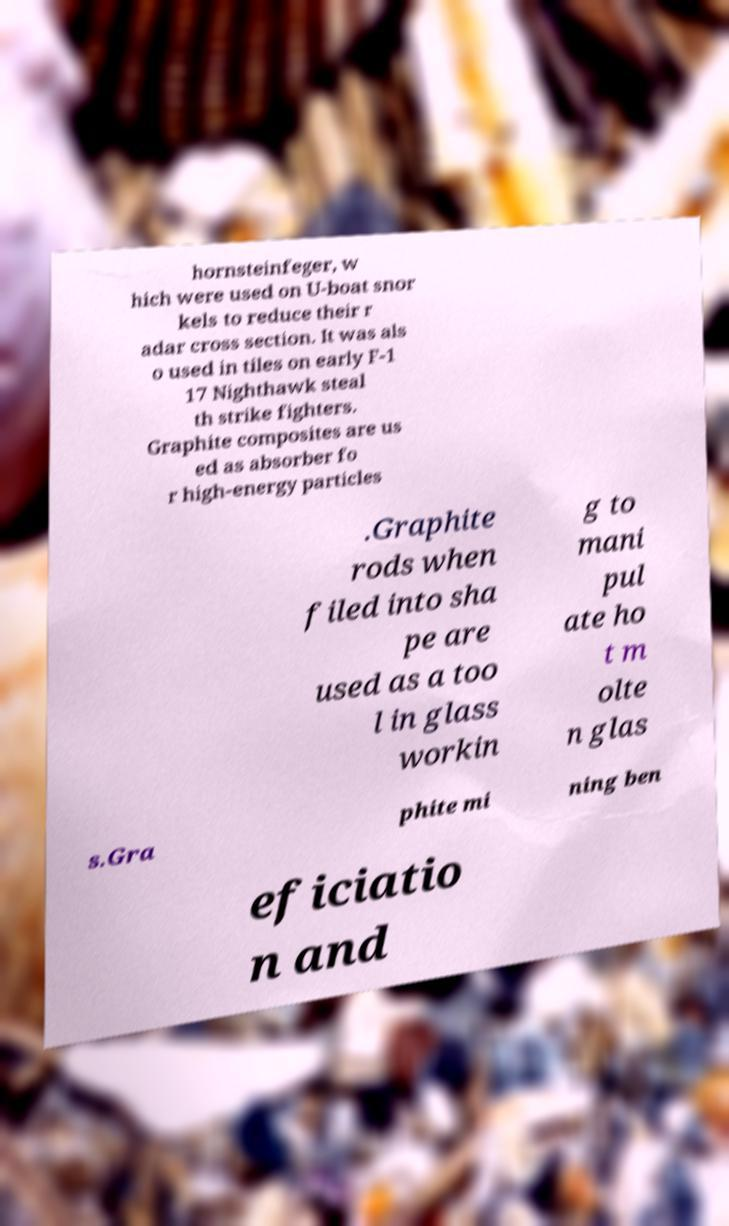Could you assist in decoding the text presented in this image and type it out clearly? hornsteinfeger, w hich were used on U-boat snor kels to reduce their r adar cross section. It was als o used in tiles on early F-1 17 Nighthawk steal th strike fighters. Graphite composites are us ed as absorber fo r high-energy particles .Graphite rods when filed into sha pe are used as a too l in glass workin g to mani pul ate ho t m olte n glas s.Gra phite mi ning ben eficiatio n and 